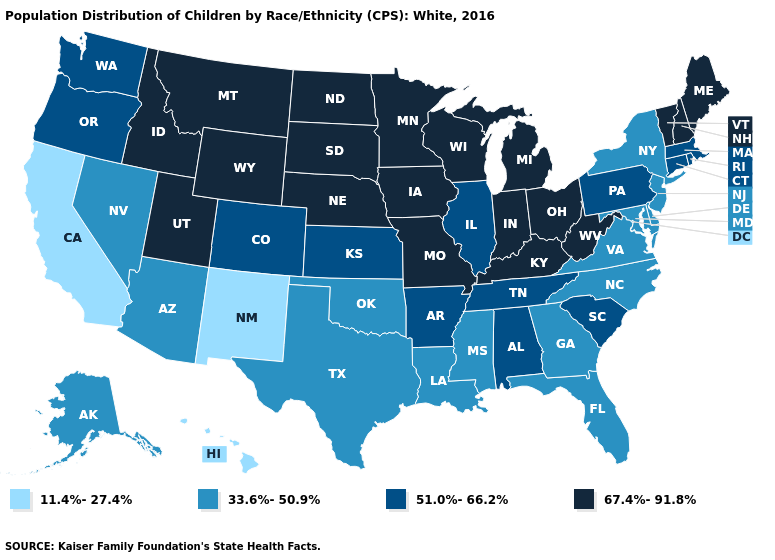Does New Mexico have the lowest value in the USA?
Short answer required. Yes. What is the lowest value in the Northeast?
Be succinct. 33.6%-50.9%. Does Kansas have the highest value in the USA?
Concise answer only. No. Name the states that have a value in the range 51.0%-66.2%?
Answer briefly. Alabama, Arkansas, Colorado, Connecticut, Illinois, Kansas, Massachusetts, Oregon, Pennsylvania, Rhode Island, South Carolina, Tennessee, Washington. Name the states that have a value in the range 67.4%-91.8%?
Write a very short answer. Idaho, Indiana, Iowa, Kentucky, Maine, Michigan, Minnesota, Missouri, Montana, Nebraska, New Hampshire, North Dakota, Ohio, South Dakota, Utah, Vermont, West Virginia, Wisconsin, Wyoming. Among the states that border South Carolina , which have the highest value?
Be succinct. Georgia, North Carolina. What is the value of Virginia?
Give a very brief answer. 33.6%-50.9%. Which states have the lowest value in the West?
Be succinct. California, Hawaii, New Mexico. What is the value of Mississippi?
Write a very short answer. 33.6%-50.9%. Among the states that border Oregon , which have the lowest value?
Quick response, please. California. Name the states that have a value in the range 11.4%-27.4%?
Be succinct. California, Hawaii, New Mexico. Name the states that have a value in the range 51.0%-66.2%?
Be succinct. Alabama, Arkansas, Colorado, Connecticut, Illinois, Kansas, Massachusetts, Oregon, Pennsylvania, Rhode Island, South Carolina, Tennessee, Washington. Does Florida have the highest value in the South?
Give a very brief answer. No. Does Virginia have a lower value than New Mexico?
Answer briefly. No. Name the states that have a value in the range 51.0%-66.2%?
Concise answer only. Alabama, Arkansas, Colorado, Connecticut, Illinois, Kansas, Massachusetts, Oregon, Pennsylvania, Rhode Island, South Carolina, Tennessee, Washington. 